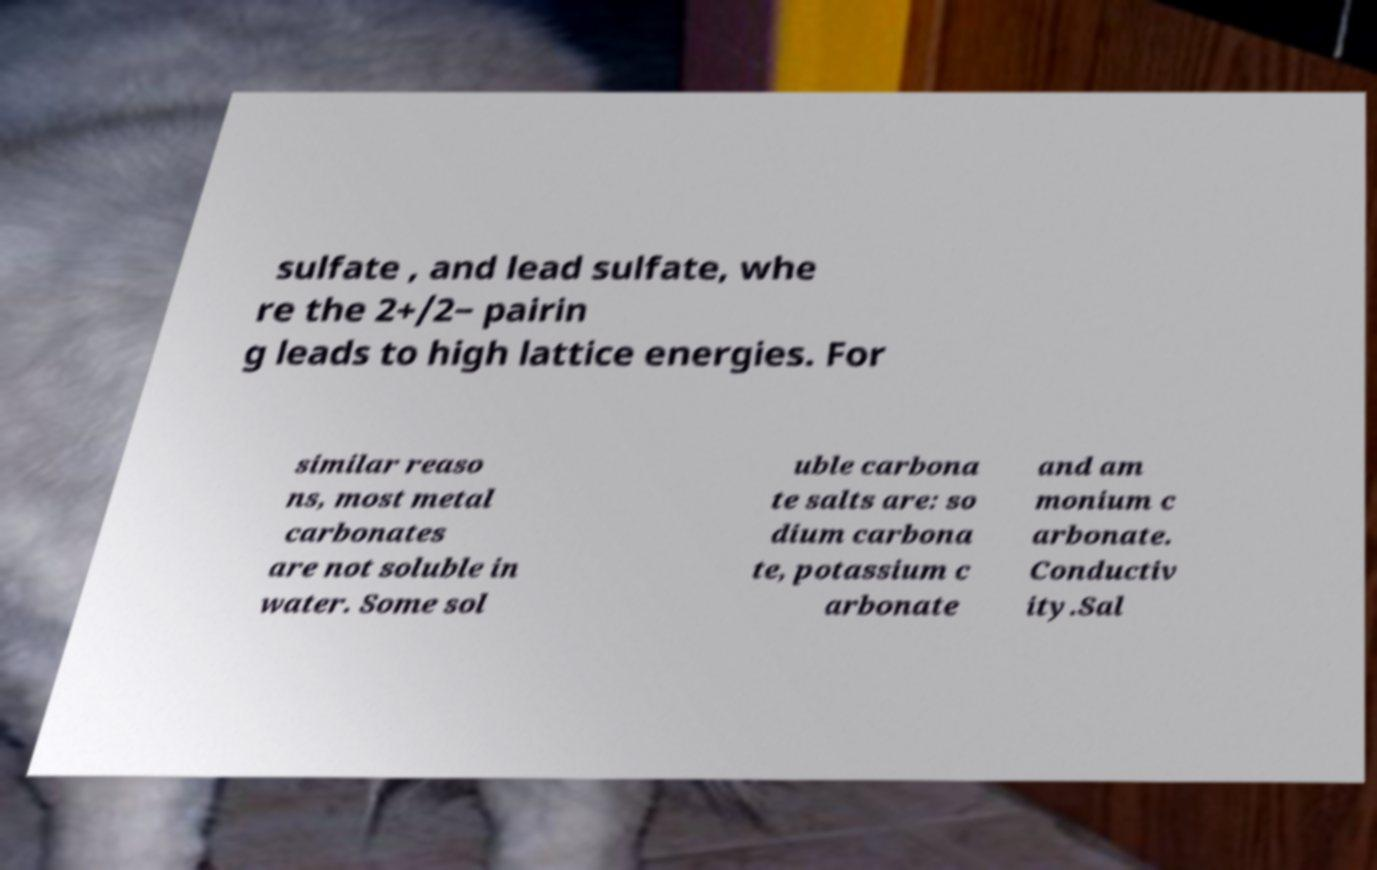Can you read and provide the text displayed in the image?This photo seems to have some interesting text. Can you extract and type it out for me? sulfate , and lead sulfate, whe re the 2+/2− pairin g leads to high lattice energies. For similar reaso ns, most metal carbonates are not soluble in water. Some sol uble carbona te salts are: so dium carbona te, potassium c arbonate and am monium c arbonate. Conductiv ity.Sal 